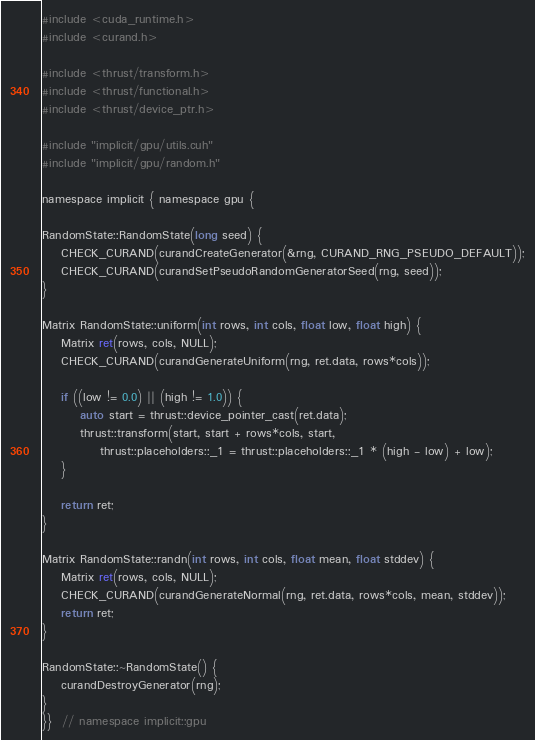Convert code to text. <code><loc_0><loc_0><loc_500><loc_500><_Cuda_>#include <cuda_runtime.h>
#include <curand.h>

#include <thrust/transform.h>
#include <thrust/functional.h>
#include <thrust/device_ptr.h>

#include "implicit/gpu/utils.cuh"
#include "implicit/gpu/random.h"

namespace implicit { namespace gpu {

RandomState::RandomState(long seed) {
    CHECK_CURAND(curandCreateGenerator(&rng, CURAND_RNG_PSEUDO_DEFAULT));
    CHECK_CURAND(curandSetPseudoRandomGeneratorSeed(rng, seed));
}

Matrix RandomState::uniform(int rows, int cols, float low, float high) {
    Matrix ret(rows, cols, NULL);
    CHECK_CURAND(curandGenerateUniform(rng, ret.data, rows*cols));

    if ((low != 0.0) || (high != 1.0)) {
        auto start = thrust::device_pointer_cast(ret.data);
        thrust::transform(start, start + rows*cols, start,
            thrust::placeholders::_1 = thrust::placeholders::_1 * (high - low) + low);
    }

    return ret;
}

Matrix RandomState::randn(int rows, int cols, float mean, float stddev) {
    Matrix ret(rows, cols, NULL);
    CHECK_CURAND(curandGenerateNormal(rng, ret.data, rows*cols, mean, stddev));
    return ret;
}

RandomState::~RandomState() {
    curandDestroyGenerator(rng);
}
}}  // namespace implicit::gpu
</code> 